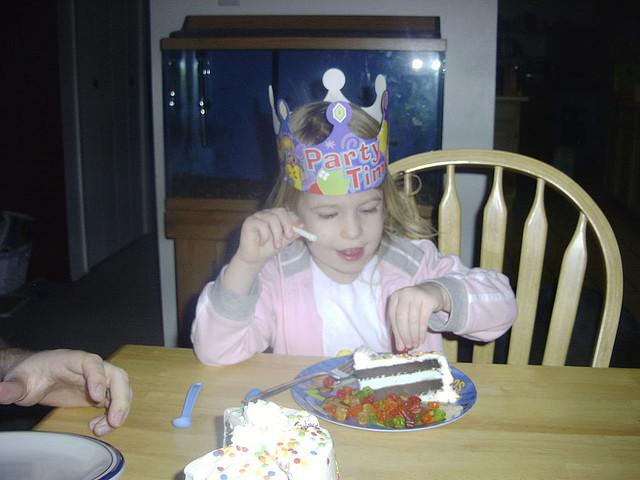What kind of food is in the bowl?
Quick response, please. Cake. What kind of hairstyle does the girl have?
Answer briefly. Straight. What kind of frosting is on the table?
Quick response, please. White. Why is the girl wearing a hat?
Concise answer only. Birthday. How many spoons are touching the plate?
Short answer required. 0. What kind of food is the girl eating?
Quick response, please. Cake. Does one of the dishes have meat in it?
Answer briefly. No. What room is the child in?
Be succinct. Dining room. What color is the chair?
Give a very brief answer. Tan. Is the baby a boy or girl?
Be succinct. Girl. 